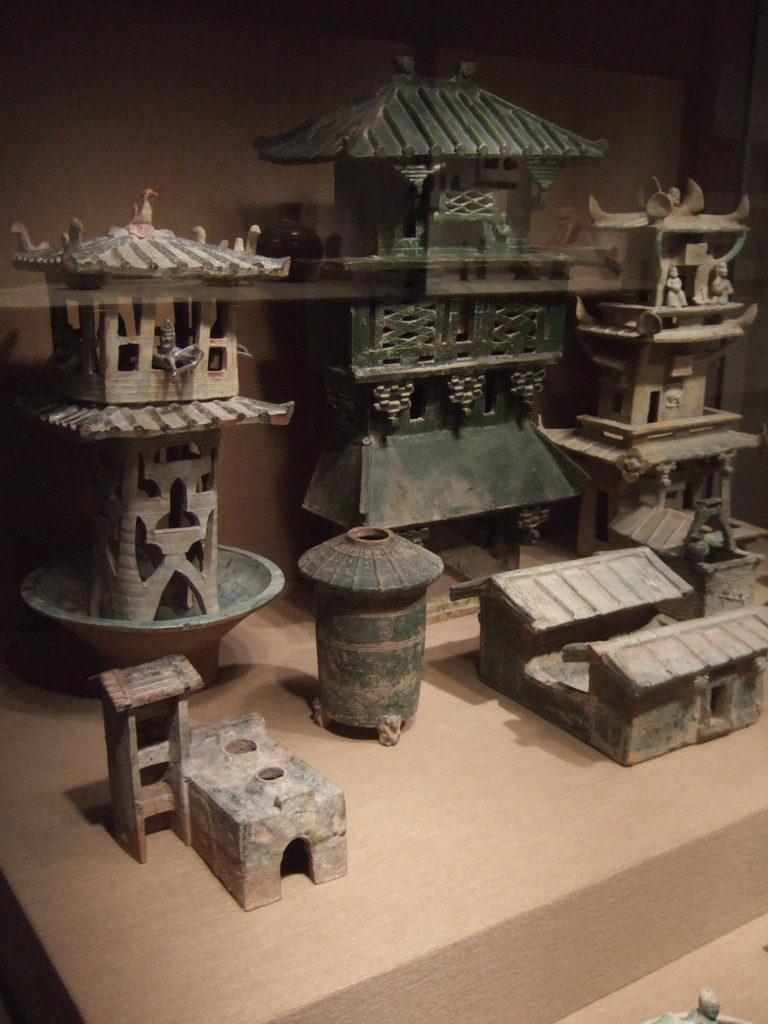What is the main subject of the image? The main subject of the image is miniature buildings on a platform. Can you describe the setting of the image? There is a wall in the background of the image. How many dogs are visible in the image? There are no dogs present in the image. What is the value of the kettle in the image? There is no kettle present in the image, so it is not possible to determine its value. 